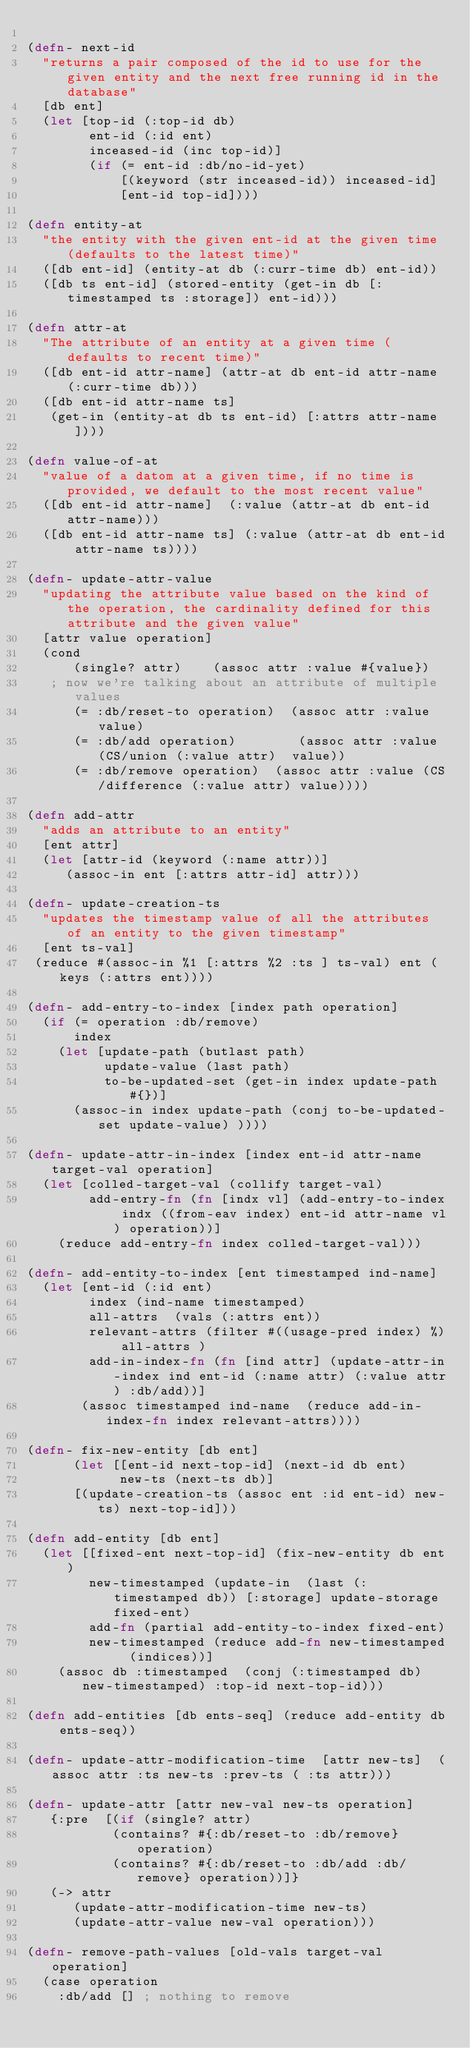<code> <loc_0><loc_0><loc_500><loc_500><_Clojure_>
(defn- next-id
  "returns a pair composed of the id to use for the given entity and the next free running id in the database"
  [db ent]
  (let [top-id (:top-id db)
        ent-id (:id ent)
        inceased-id (inc top-id)]
        (if (= ent-id :db/no-id-yet)
            [(keyword (str inceased-id)) inceased-id]
            [ent-id top-id])))

(defn entity-at
  "the entity with the given ent-id at the given time (defaults to the latest time)"
  ([db ent-id] (entity-at db (:curr-time db) ent-id))
  ([db ts ent-id] (stored-entity (get-in db [:timestamped ts :storage]) ent-id)))

(defn attr-at
  "The attribute of an entity at a given time (defaults to recent time)"
  ([db ent-id attr-name] (attr-at db ent-id attr-name (:curr-time db)))
  ([db ent-id attr-name ts]
   (get-in (entity-at db ts ent-id) [:attrs attr-name])))

(defn value-of-at
  "value of a datom at a given time, if no time is provided, we default to the most recent value"
  ([db ent-id attr-name]  (:value (attr-at db ent-id attr-name)))
  ([db ent-id attr-name ts] (:value (attr-at db ent-id attr-name ts))))

(defn- update-attr-value
  "updating the attribute value based on the kind of the operation, the cardinality defined for this attribute and the given value"
  [attr value operation]
  (cond
      (single? attr)    (assoc attr :value #{value})
   ; now we're talking about an attribute of multiple values
      (= :db/reset-to operation)  (assoc attr :value value)
      (= :db/add operation)        (assoc attr :value (CS/union (:value attr)  value))
      (= :db/remove operation)  (assoc attr :value (CS/difference (:value attr) value))))

(defn add-attr
  "adds an attribute to an entity"
  [ent attr]
  (let [attr-id (keyword (:name attr))]
     (assoc-in ent [:attrs attr-id] attr)))

(defn- update-creation-ts
  "updates the timestamp value of all the attributes of an entity to the given timestamp"
  [ent ts-val]
 (reduce #(assoc-in %1 [:attrs %2 :ts ] ts-val) ent (keys (:attrs ent))))

(defn- add-entry-to-index [index path operation]
  (if (= operation :db/remove)
      index
    (let [update-path (butlast path)
          update-value (last path)
          to-be-updated-set (get-in index update-path #{})]
      (assoc-in index update-path (conj to-be-updated-set update-value) ))))

(defn- update-attr-in-index [index ent-id attr-name target-val operation]
  (let [colled-target-val (collify target-val)
        add-entry-fn (fn [indx vl] (add-entry-to-index indx ((from-eav index) ent-id attr-name vl) operation))]
    (reduce add-entry-fn index colled-target-val)))

(defn- add-entity-to-index [ent timestamped ind-name]
  (let [ent-id (:id ent)
        index (ind-name timestamped)
        all-attrs  (vals (:attrs ent))
        relevant-attrs (filter #((usage-pred index) %) all-attrs )
        add-in-index-fn (fn [ind attr] (update-attr-in-index ind ent-id (:name attr) (:value attr) :db/add))]
       (assoc timestamped ind-name  (reduce add-in-index-fn index relevant-attrs))))

(defn- fix-new-entity [db ent]
      (let [[ent-id next-top-id] (next-id db ent)
            new-ts (next-ts db)]
      [(update-creation-ts (assoc ent :id ent-id) new-ts) next-top-id]))

(defn add-entity [db ent]
  (let [[fixed-ent next-top-id] (fix-new-entity db ent)
        new-timestamped (update-in  (last (:timestamped db)) [:storage] update-storage fixed-ent)
        add-fn (partial add-entity-to-index fixed-ent)
        new-timestamped (reduce add-fn new-timestamped  (indices))]
    (assoc db :timestamped  (conj (:timestamped db) new-timestamped) :top-id next-top-id)))

(defn add-entities [db ents-seq] (reduce add-entity db ents-seq))

(defn- update-attr-modification-time  [attr new-ts]  (assoc attr :ts new-ts :prev-ts ( :ts attr)))

(defn- update-attr [attr new-val new-ts operation]
   {:pre  [(if (single? attr)
           (contains? #{:db/reset-to :db/remove} operation)
           (contains? #{:db/reset-to :db/add :db/remove} operation))]}
   (-> attr
      (update-attr-modification-time new-ts)
      (update-attr-value new-val operation)))

(defn- remove-path-values [old-vals target-val operation]
  (case operation
    :db/add [] ; nothing to remove</code> 